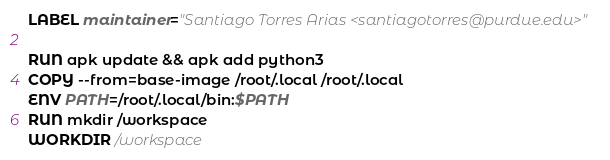Convert code to text. <code><loc_0><loc_0><loc_500><loc_500><_Dockerfile_>LABEL maintainer="Santiago Torres Arias <santiagotorres@purdue.edu>"

RUN apk update && apk add python3
COPY --from=base-image /root/.local /root/.local
ENV PATH=/root/.local/bin:$PATH
RUN mkdir /workspace
WORKDIR /workspace
</code> 